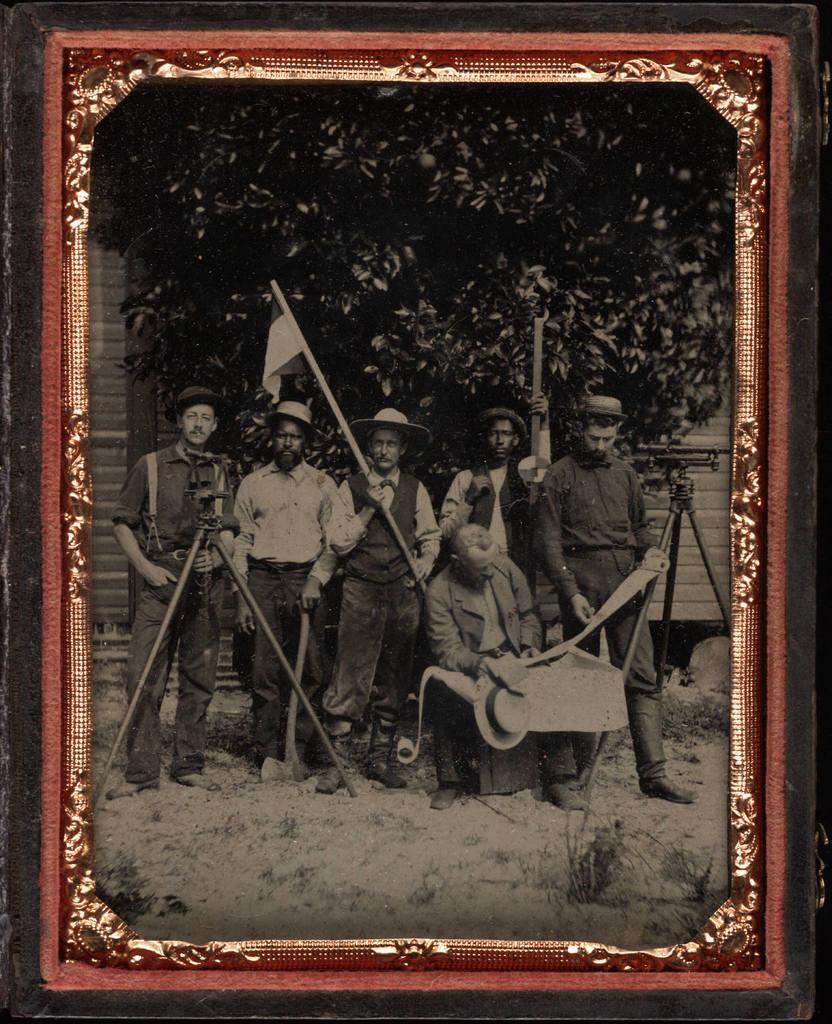Can you describe this image briefly? In this picture we can see a photo frame, where we can see people on the ground and in the background we can see a wall, trees. 